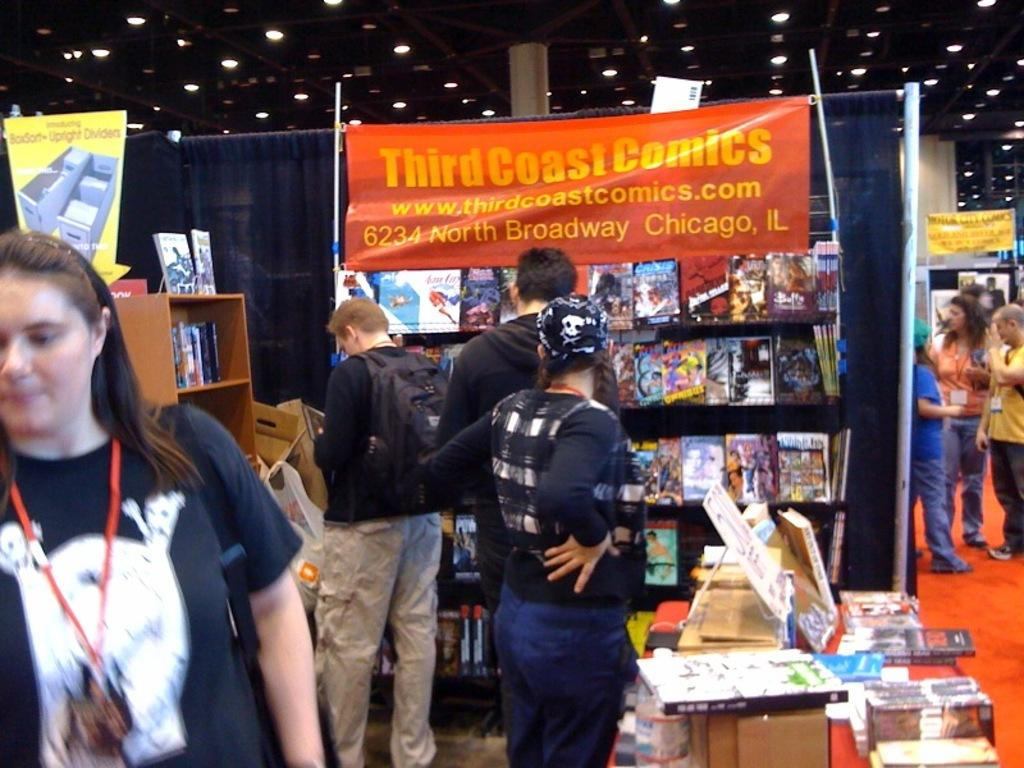Provide a one-sentence caption for the provided image. People look through displays of Third Coast Comics. 